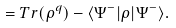<formula> <loc_0><loc_0><loc_500><loc_500>\text { \quad \ \ } = T r ( \rho ^ { q } ) - \langle \Psi ^ { - } | \rho | \Psi ^ { - } \rangle .</formula> 